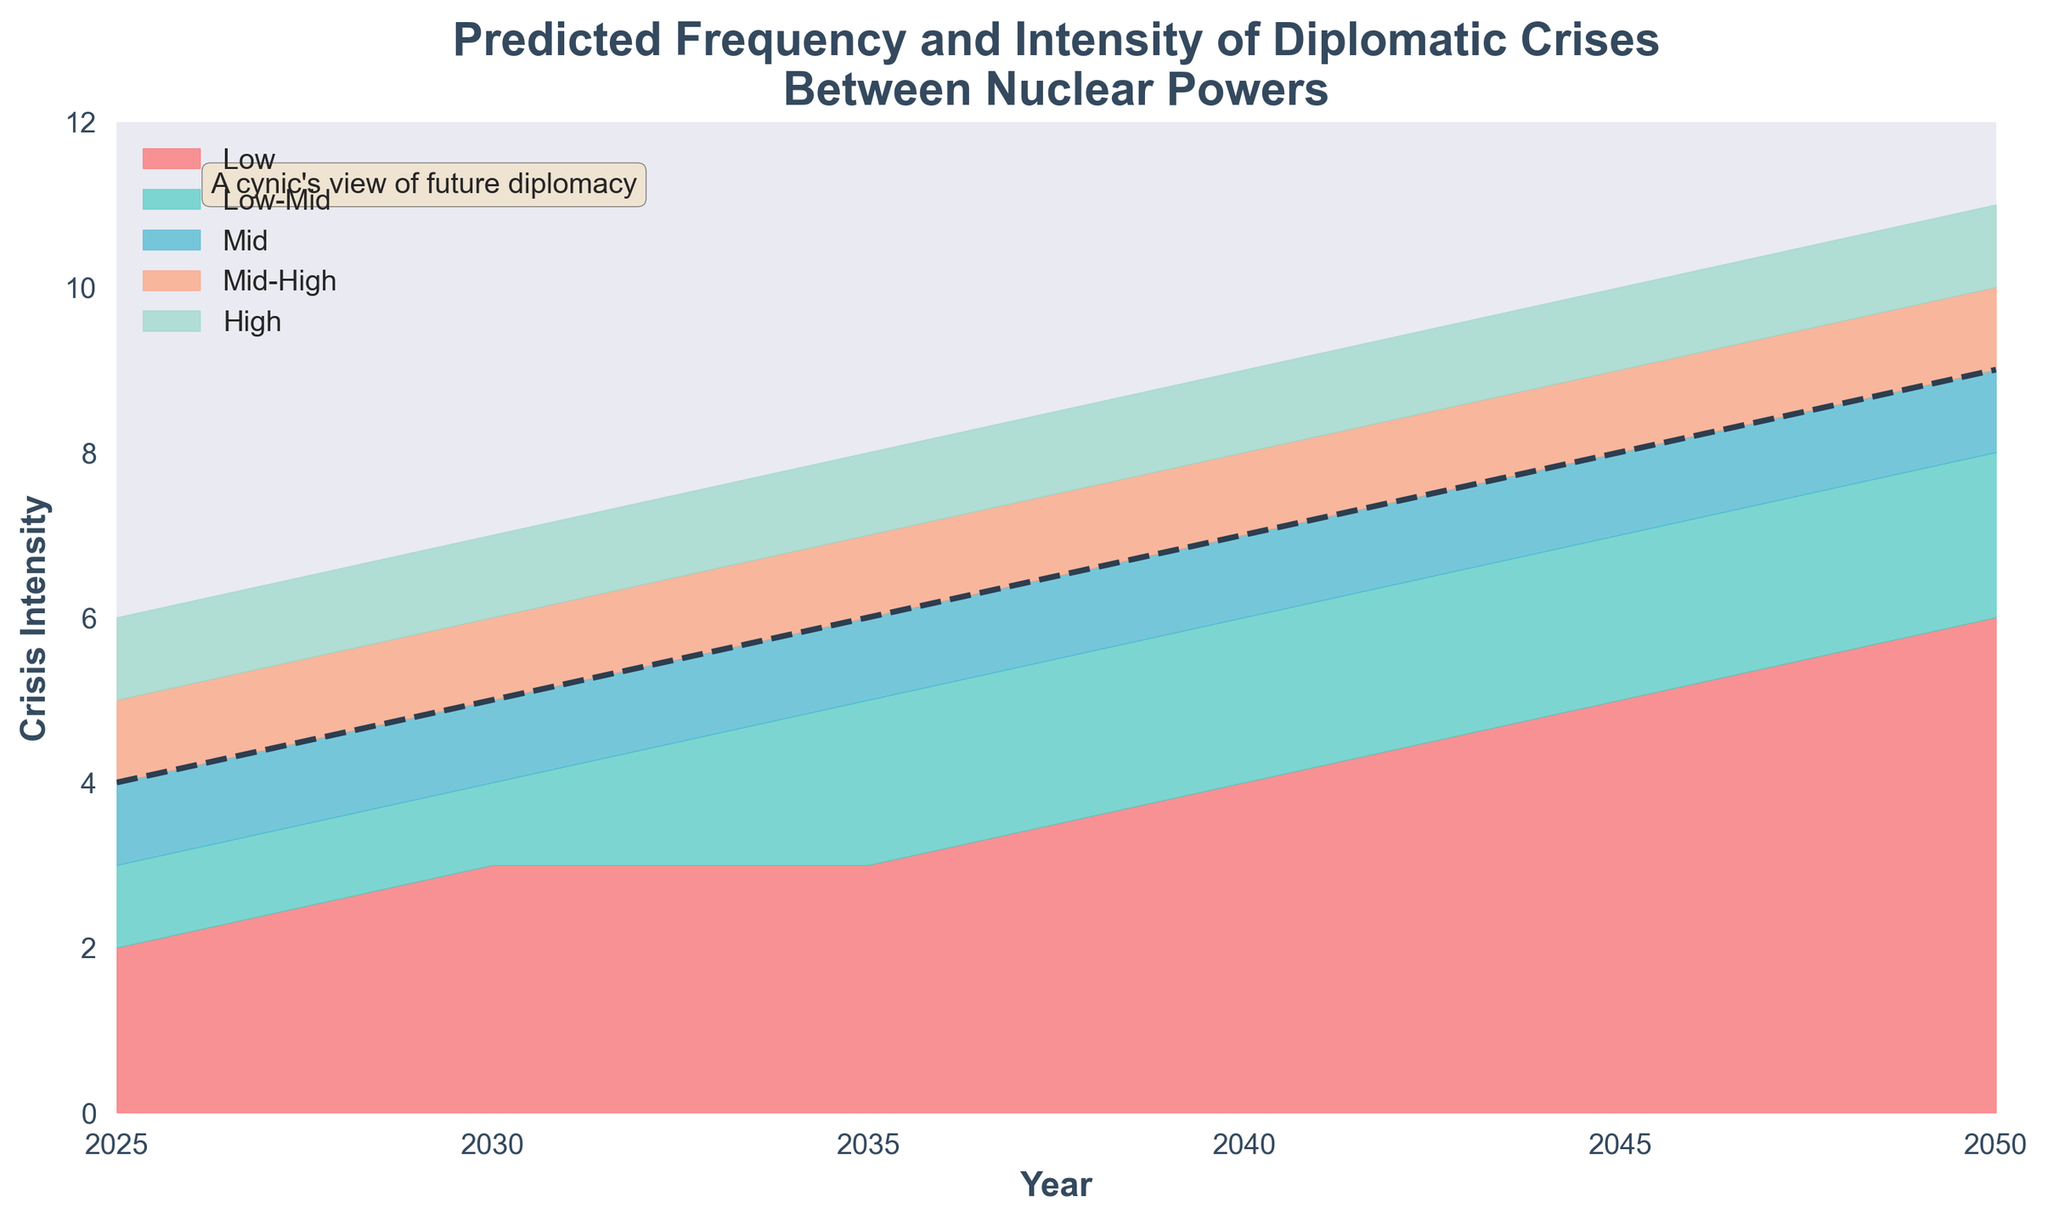What is the title of the figure? The title is located at the top of the figure and reads, "Predicted Frequency and Intensity of Diplomatic Crises Between Nuclear Powers".
Answer: Predicted Frequency and Intensity of Diplomatic Crises Between Nuclear Powers What is the crisis intensity in 2030 for the 'Mid' category? The 'Mid' category can be found along the midline of the filled areas. In 2030, the intensity for 'Mid' is marked at 5.
Answer: 5 What does the dashed line in the middle represent? The dashed line in the middle represents the 'Mid' category, which is the median or central prediction of crisis intensity.
Answer: The 'Mid' category Which year shows the highest predicted frequency and intensity for the 'High' category? By looking at the topmost filled area in different years, 2050 has the highest predicted intensity for the 'High' category with a value of 11.
Answer: 2050 How does the predicted crisis intensity for the 'Low' category change from 2025 to 2045? Observing the lower-most filled area, the 'Low' category's intensity increases from 2 in 2025 to 5 in 2045.
Answer: It rises from 2 to 5 What is the average predicted crisis intensity for the 'Mid-High' category in 2035 and 2045? In 2035, the 'Mid-High' category has an intensity of 7, and in 2045, it is 9. The average is calculated as (7 + 9) / 2 = 8.
Answer: 8 Which category shows the largest increase in crisis intensity from 2040 to 2050? Reviewing the data for each category, the 'Low' category increases from 4 in 2040 to 6 in 2050, the 'Low-Mid' from 6 to 8, the 'Mid' from 7 to 9, the 'Mid-High' from 8 to 10, and the 'High' from 9 to 11. Each category increases by the same amount: 2 points.
Answer: All categories show the same increase What is the hue of the area representing the 'Low-Mid' category? The color for the ‘Low-Mid’ category area is a shade of teal or bluish-green.
Answer: Teal or bluish-green In which year do the 'Low' and 'High' categories show the closest predicted crisis intensities? Comparing the intensities, the difference between 'Low' and 'High' categories is smallest in 2025, where 'Low' is 2 and 'High' is 6, with a difference of 4.
Answer: 2025 Does the fan chart indicate any period of decline in predicted crisis intensity for any category? Examining the trends for each category over time, all categories show a consistent increase in predicted crisis intensity without any period of decline.
Answer: No 